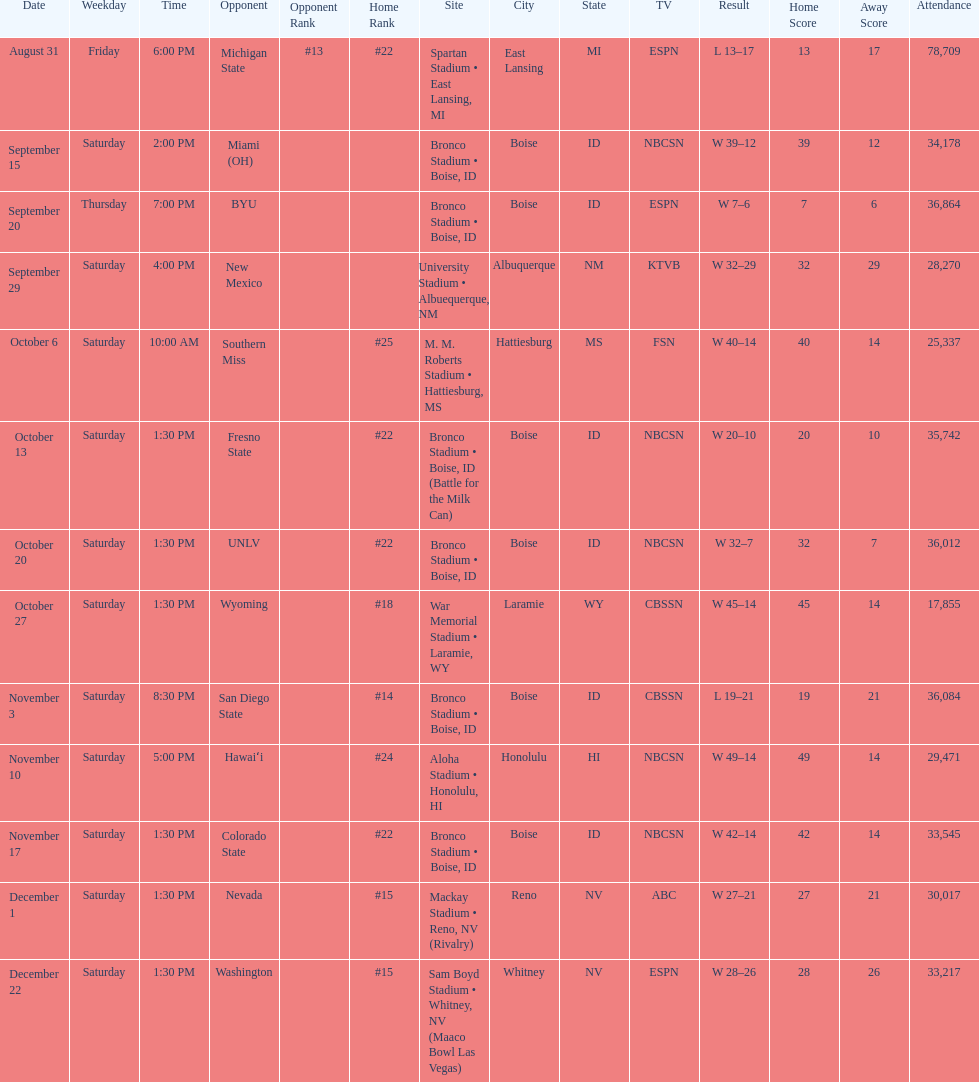Opponent broncos faced next after unlv Wyoming. 